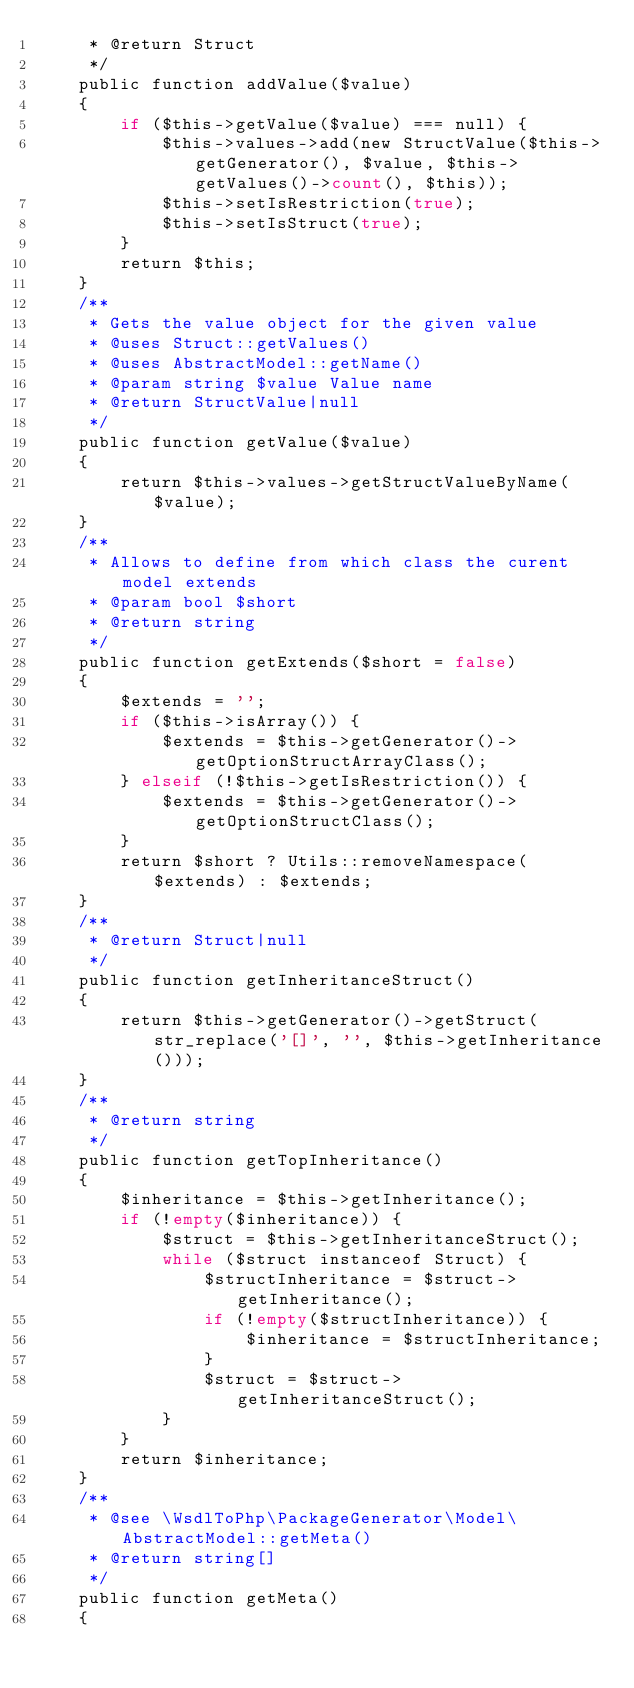Convert code to text. <code><loc_0><loc_0><loc_500><loc_500><_PHP_>     * @return Struct
     */
    public function addValue($value)
    {
        if ($this->getValue($value) === null) {
            $this->values->add(new StructValue($this->getGenerator(), $value, $this->getValues()->count(), $this));
            $this->setIsRestriction(true);
            $this->setIsStruct(true);
        }
        return $this;
    }
    /**
     * Gets the value object for the given value
     * @uses Struct::getValues()
     * @uses AbstractModel::getName()
     * @param string $value Value name
     * @return StructValue|null
     */
    public function getValue($value)
    {
        return $this->values->getStructValueByName($value);
    }
    /**
     * Allows to define from which class the curent model extends
     * @param bool $short
     * @return string
     */
    public function getExtends($short = false)
    {
        $extends = '';
        if ($this->isArray()) {
            $extends = $this->getGenerator()->getOptionStructArrayClass();
        } elseif (!$this->getIsRestriction()) {
            $extends = $this->getGenerator()->getOptionStructClass();
        }
        return $short ? Utils::removeNamespace($extends) : $extends;
    }
    /**
     * @return Struct|null
     */
    public function getInheritanceStruct()
    {
        return $this->getGenerator()->getStruct(str_replace('[]', '', $this->getInheritance()));
    }
    /**
     * @return string
     */
    public function getTopInheritance()
    {
        $inheritance = $this->getInheritance();
        if (!empty($inheritance)) {
            $struct = $this->getInheritanceStruct();
            while ($struct instanceof Struct) {
                $structInheritance = $struct->getInheritance();
                if (!empty($structInheritance)) {
                    $inheritance = $structInheritance;
                }
                $struct = $struct->getInheritanceStruct();
            }
        }
        return $inheritance;
    }
    /**
     * @see \WsdlToPhp\PackageGenerator\Model\AbstractModel::getMeta()
     * @return string[]
     */
    public function getMeta()
    {</code> 